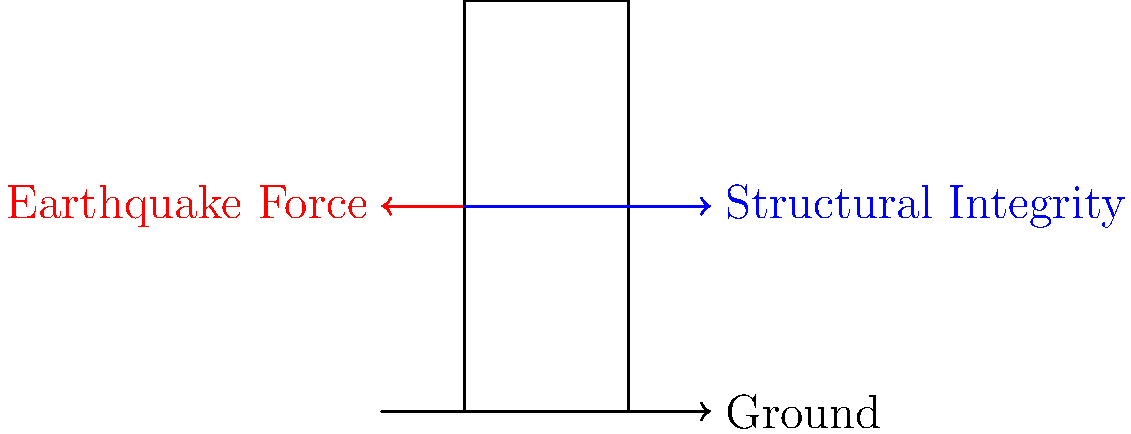In earthquake-prone regions of Africa, building structural integrity is crucial for insurance risk assessment. Consider a simplified model of a building subjected to seismic forces. If the earthquake force is represented by a horizontal vector $\vec{F_e}$ and the building's structural integrity is represented by an opposing force $\vec{F_s}$, what condition must be met to ensure the building remains stable during an earthquake? To analyze the stability of a building during an earthquake, we need to consider the forces acting on it:

1. Earthquake force ($\vec{F_e}$): This is the horizontal force exerted on the building due to seismic activity.
2. Structural integrity force ($\vec{F_s}$): This represents the building's ability to resist the earthquake force.

For the building to remain stable:

1. The magnitude of the structural integrity force must be greater than or equal to the magnitude of the earthquake force: $|\vec{F_s}| \geq |\vec{F_e}|$

2. The structural integrity force must be in the opposite direction of the earthquake force to counteract it.

3. In vector notation, this can be expressed as: $\vec{F_s} + \vec{F_e} = \vec{0}$

4. This condition ensures that the net force on the building is zero, preventing collapse or significant displacement.

5. In practical terms, this means the building's design, materials, and construction techniques must be capable of withstanding the maximum expected seismic forces in the region.

6. For insurance purposes, this analysis helps in assessing the risk and potential damage to buildings in earthquake-prone areas, which is crucial for determining premiums and coverage in African regions with seismic activity.
Answer: $|\vec{F_s}| \geq |\vec{F_e}|$ and $\vec{F_s} + \vec{F_e} = \vec{0}$ 